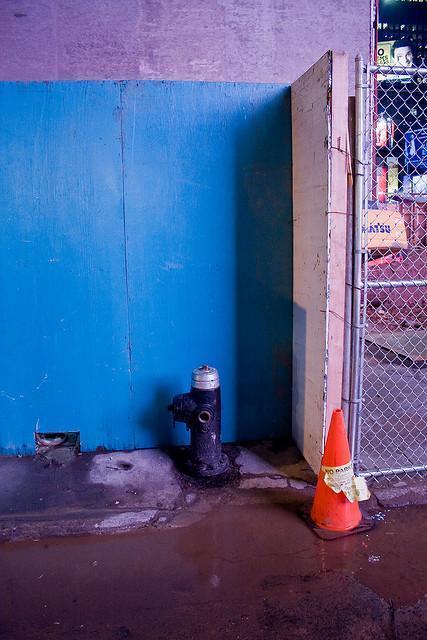How many fire hydrants are there?
Give a very brief answer. 1. 